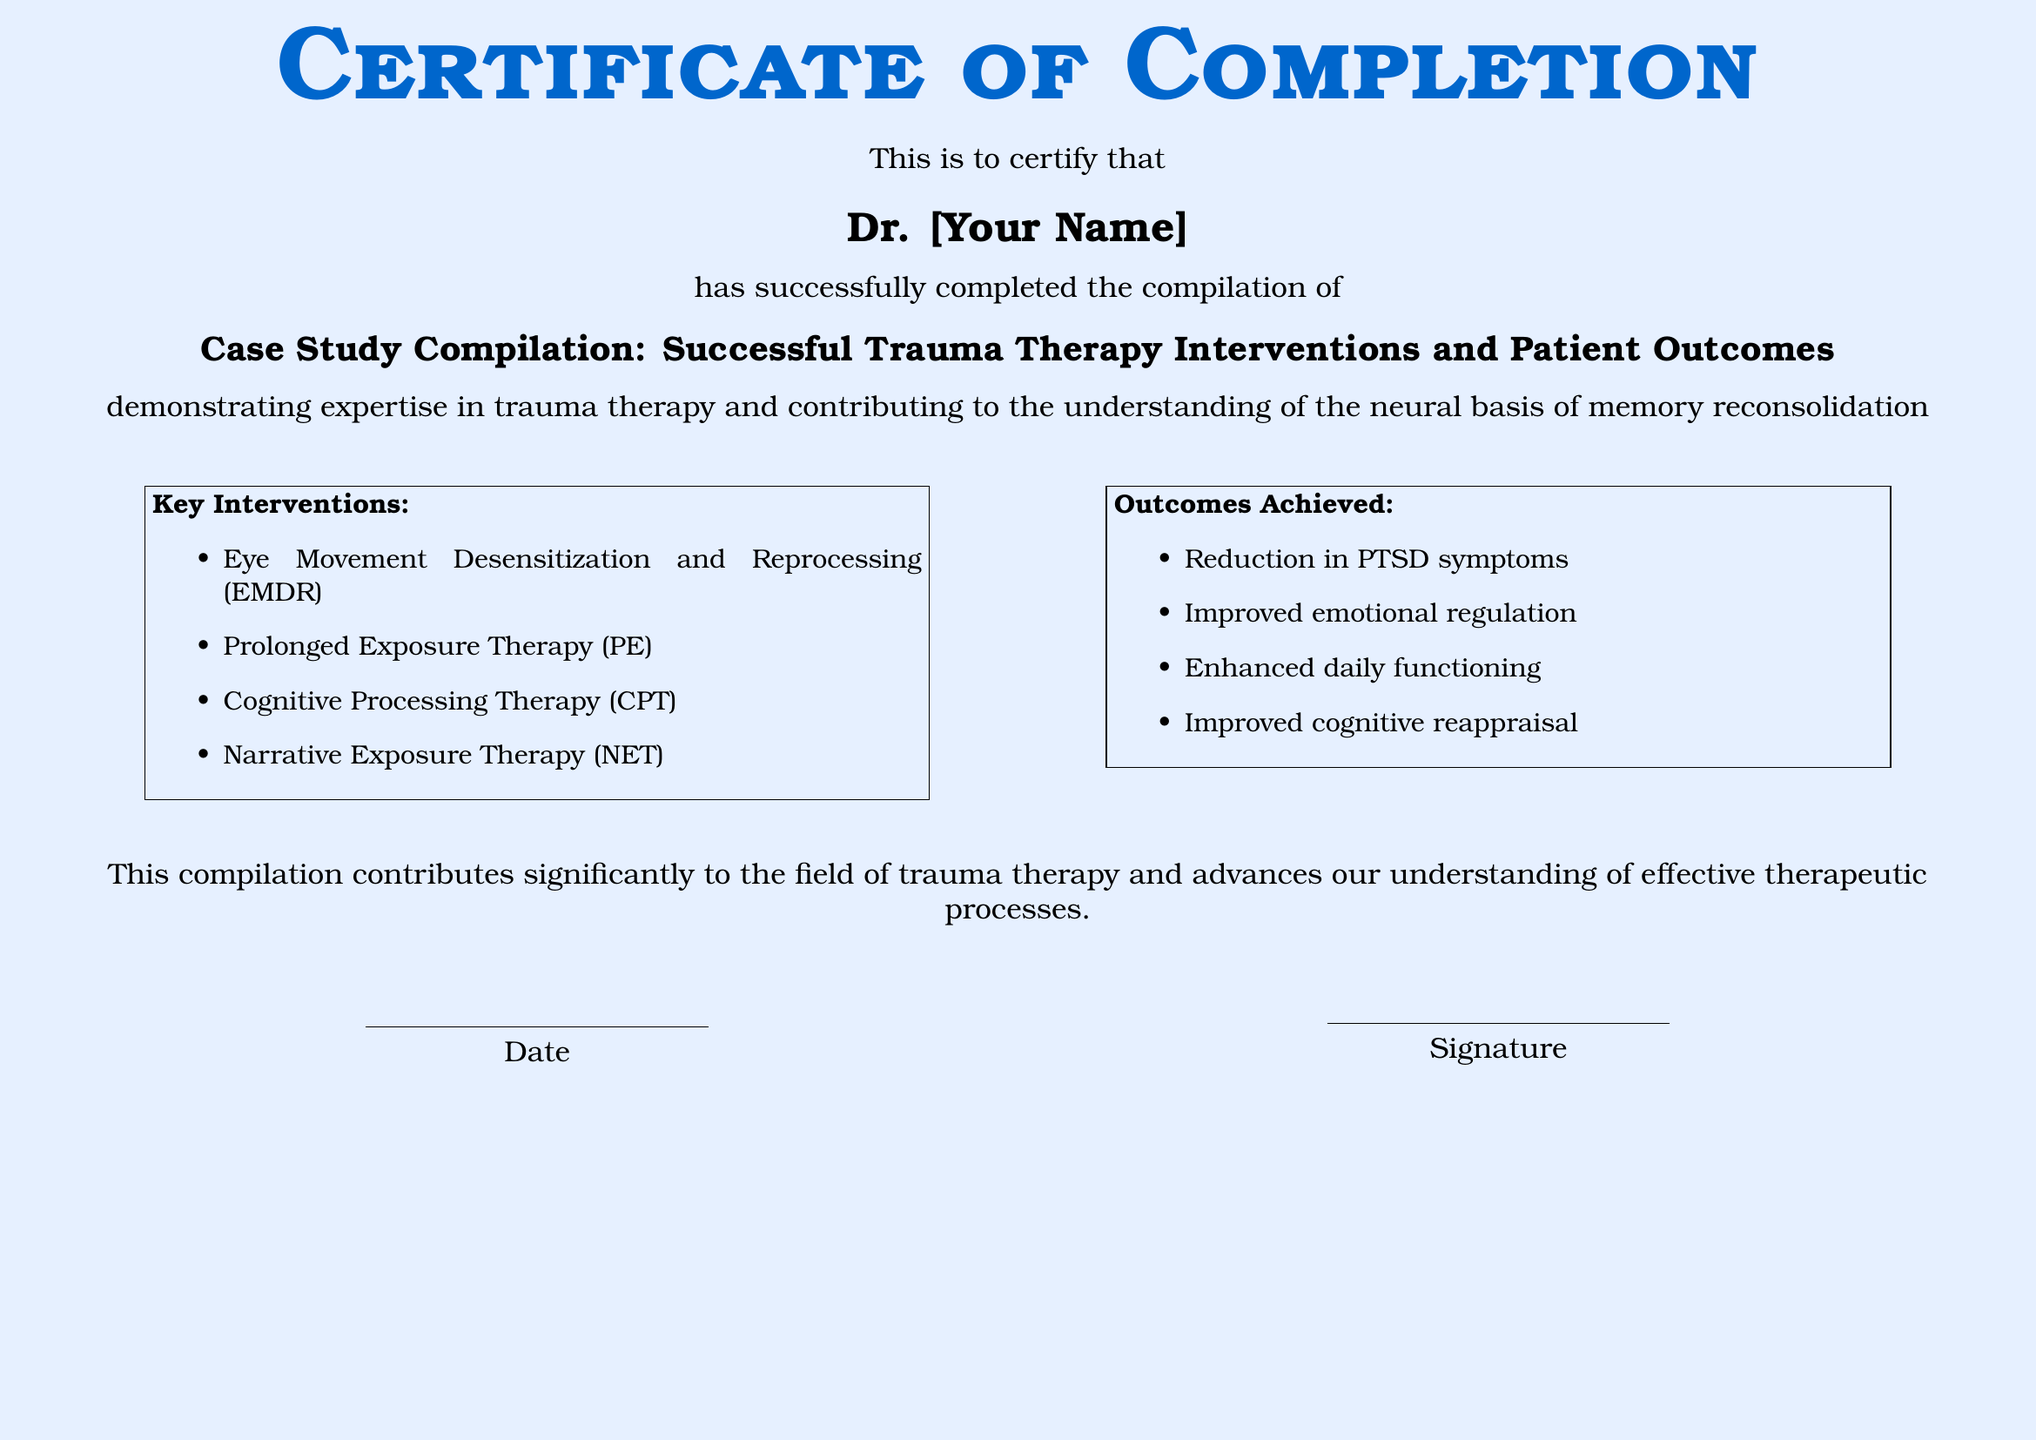What is the diploma certification title? The title of the certification is specifically mentioned in the document as the "Certificate of Completion."
Answer: Certificate of Completion Who completed the case study compilation? The document states that Dr. [Your Name] completed the case study compilation, where [Your Name] is a placeholder for the actual name.
Answer: Dr. [Your Name] What is the subject of the case study compilation? The subject of the case study compilation is highlighted as "Case Study Compilation: Successful Trauma Therapy Interventions and Patient Outcomes."
Answer: Successful Trauma Therapy Interventions and Patient Outcomes What was one of the key interventions listed? The document lists several key interventions; one of them is "Eye Movement Desensitization and Reprocessing (EMDR)."
Answer: Eye Movement Desensitization and Reprocessing What is one outcome achieved from the therapy? The document mentions "Reduction in PTSD symptoms" as one of the outcomes achieved.
Answer: Reduction in PTSD symptoms What color is the background of the diploma? The diploma features a light blue background, referred to as "mylightblue" in the document's code.
Answer: Light blue How many key interventions are listed? The document presents a list under key interventions that includes four separate items.
Answer: Four What date is to be filled in on the diploma? The document has a placeholder for the date, which is indicated by a blank line for completion.
Answer: Date What does the diploma contribute to? The document states that it contributes significantly to the field of trauma therapy.
Answer: Field of trauma therapy 